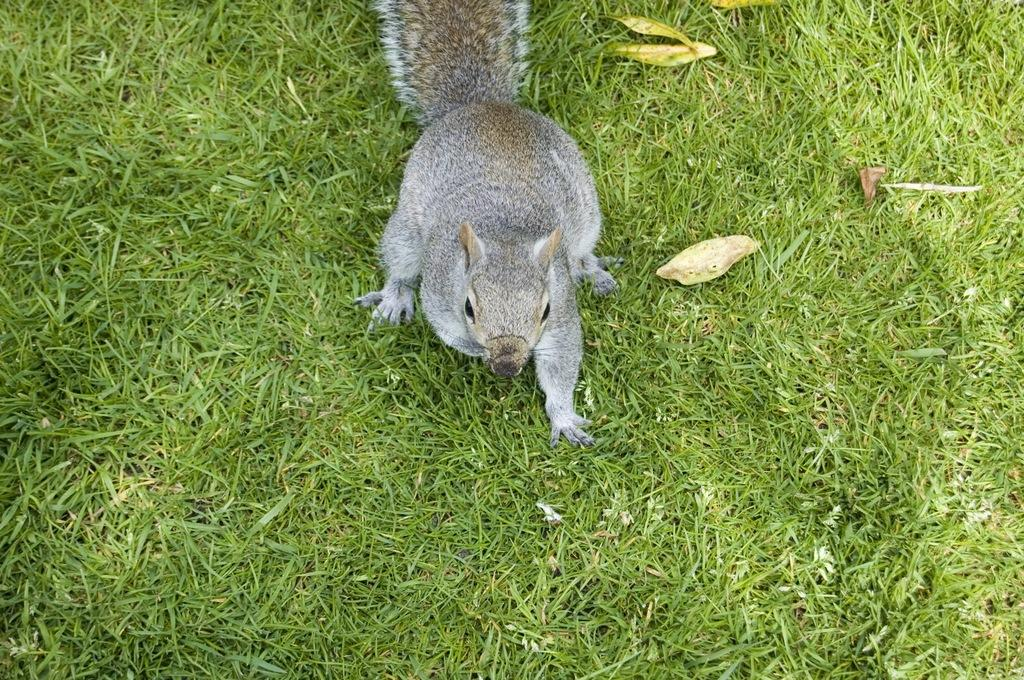What is the main subject in the center of the image? There is a squirrel in the center of the image. What type of vegetation is present at the bottom of the image? There is grass and leaves at the bottom of the image. What type of underwear is the squirrel wearing in the image? There is no underwear present in the image, as squirrels do not wear clothing. 